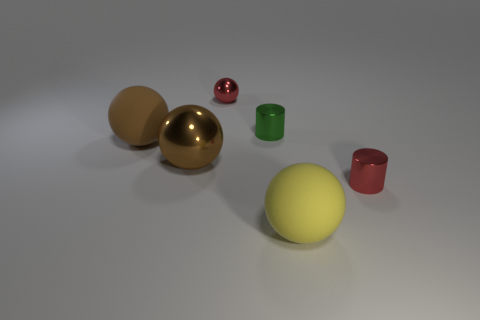Add 1 big brown balls. How many objects exist? 7 Subtract all spheres. How many objects are left? 2 Add 4 large red balls. How many large red balls exist? 4 Subtract 0 red cubes. How many objects are left? 6 Subtract all blue cylinders. Subtract all metal cylinders. How many objects are left? 4 Add 1 yellow things. How many yellow things are left? 2 